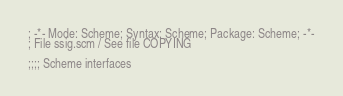<code> <loc_0><loc_0><loc_500><loc_500><_Scheme_>; -*- Mode: Scheme; Syntax: Scheme; Package: Scheme; -*-
; File ssig.scm / See file COPYING

;;;; Scheme interfaces
</code> 